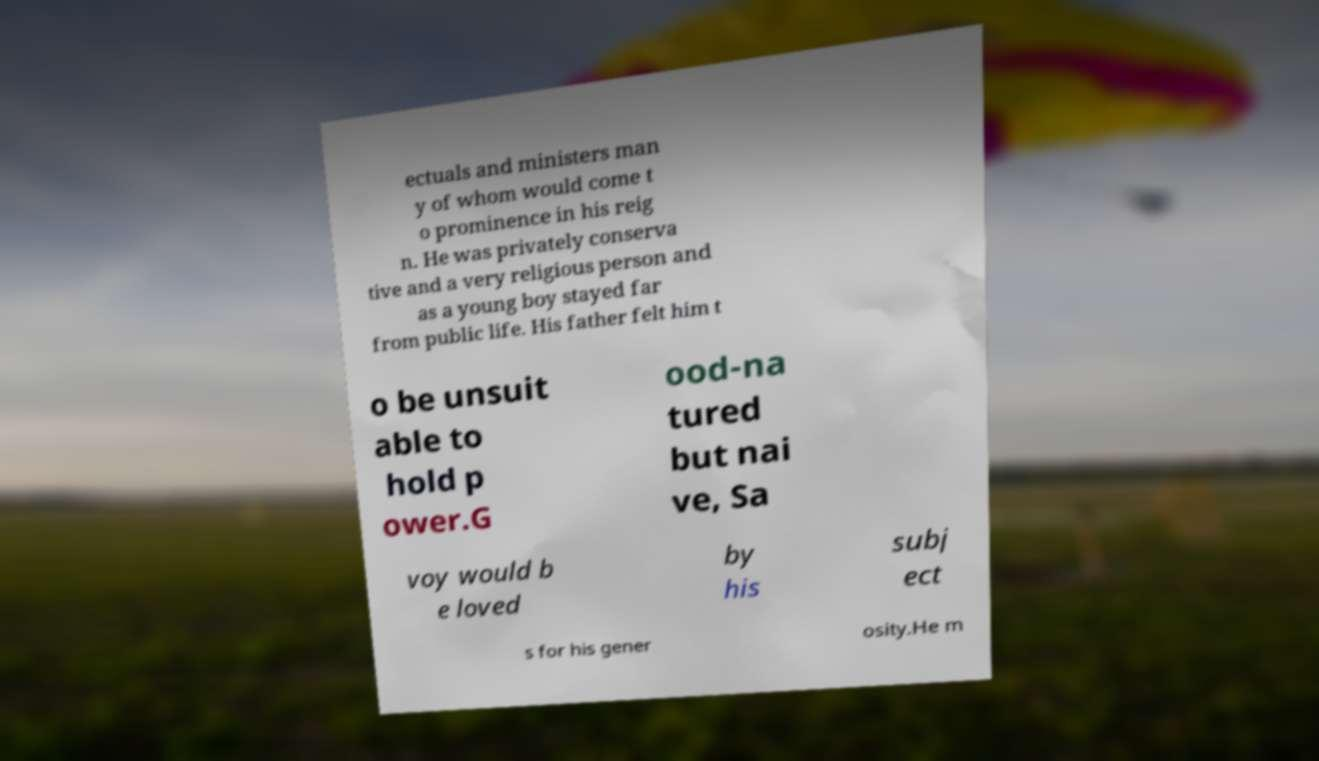Could you extract and type out the text from this image? ectuals and ministers man y of whom would come t o prominence in his reig n. He was privately conserva tive and a very religious person and as a young boy stayed far from public life. His father felt him t o be unsuit able to hold p ower.G ood-na tured but nai ve, Sa voy would b e loved by his subj ect s for his gener osity.He m 